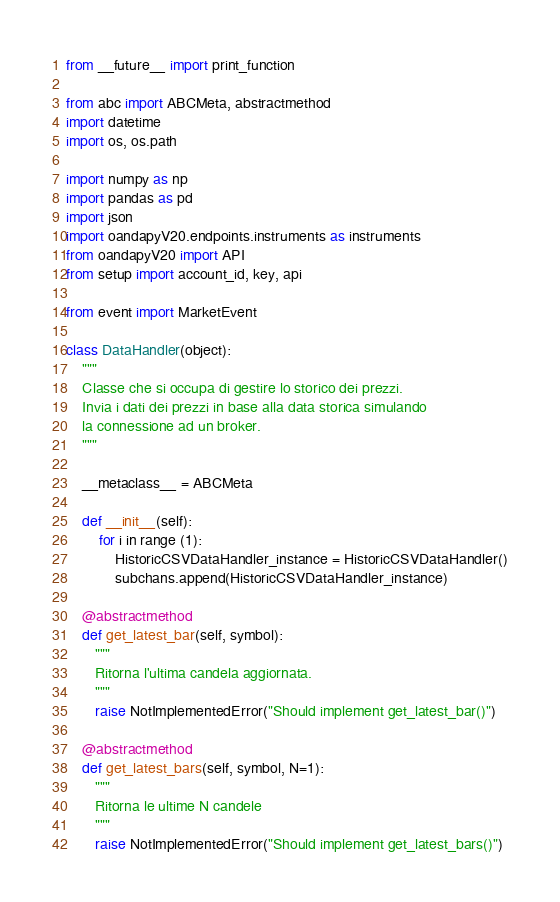Convert code to text. <code><loc_0><loc_0><loc_500><loc_500><_Python_>from __future__ import print_function

from abc import ABCMeta, abstractmethod
import datetime
import os, os.path

import numpy as np
import pandas as pd
import json
import oandapyV20.endpoints.instruments as instruments
from oandapyV20 import API
from setup import account_id, key, api

from event import MarketEvent

class DataHandler(object):
    """
    Classe che si occupa di gestire lo storico dei prezzi.
    Invia i dati dei prezzi in base alla data storica simulando
    la connessione ad un broker.
    """

    __metaclass__ = ABCMeta

    def __init__(self):
        for i in range (1):
            HistoricCSVDataHandler_instance = HistoricCSVDataHandler()
            subchans.append(HistoricCSVDataHandler_instance)

    @abstractmethod
    def get_latest_bar(self, symbol):
       """
       Ritorna l'ultima candela aggiornata.
       """
       raise NotImplementedError("Should implement get_latest_bar()")

    @abstractmethod
    def get_latest_bars(self, symbol, N=1):
       """
       Ritorna le ultime N candele
       """
       raise NotImplementedError("Should implement get_latest_bars()")
</code> 